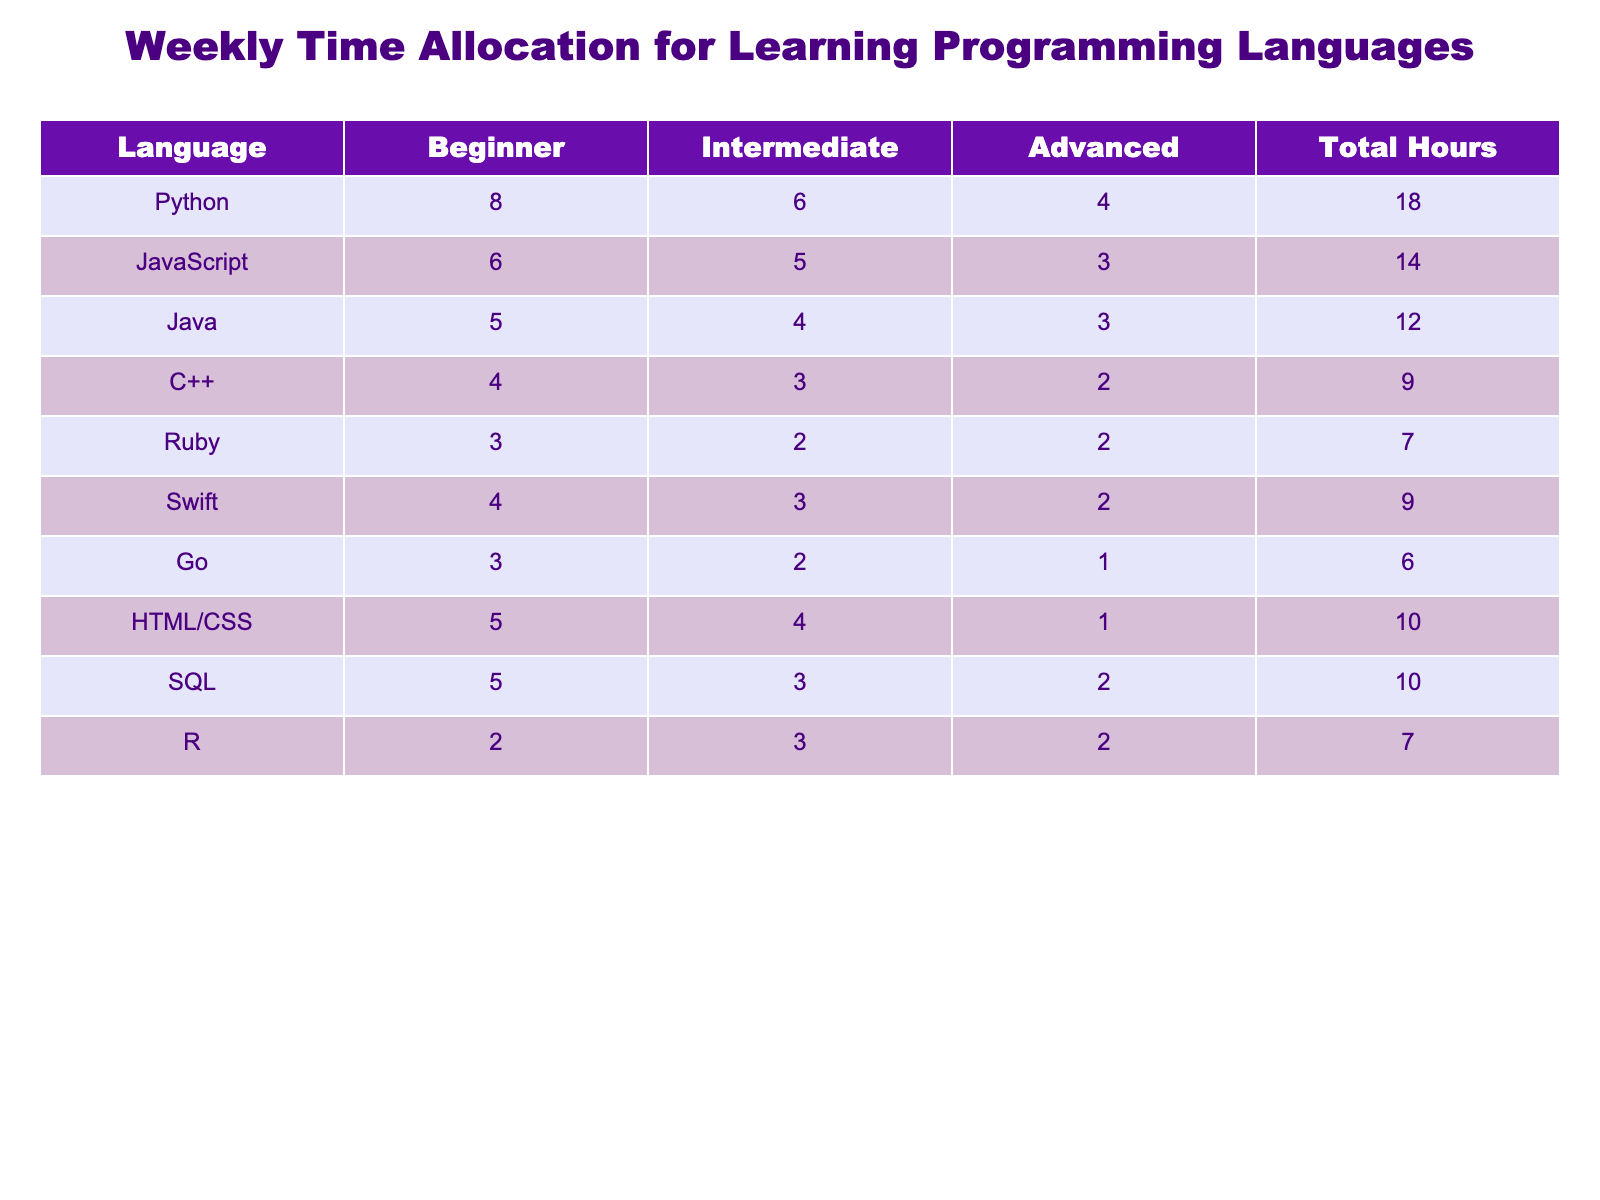What is the total number of hours allocated for learning Python? The total hours for Python can be found in the last column of the table. The row corresponding to Python shows a total of 18 hours.
Answer: 18 Which language has the highest total hours allocated for learning? To find the highest total hours, we compare the 'Total Hours' column values. Python has 18, JavaScript has 14, Java has 12, and so on. The highest is Python with 18 hours.
Answer: Python What is the average total hours allocated for all programming languages? First, we need to sum the total hours for all languages: 18 + 14 + 12 + 9 + 7 + 9 + 6 + 10 + 10 + 7 = 92. There are 10 languages, so the average is 92 divided by 10, which equals 9.2.
Answer: 9.2 Is it true that Ruby has more total hours than Go? We check the total hours for Ruby, which is 7, and compare it to Go, which has 6 hours. Since 7 is greater than 6, the statement is true.
Answer: Yes If we look at intermediate hours, which programming language has the least allocation? In the 'Intermediate' column, we list the hours: 6 for Python, 5 for JavaScript, 4 for Java, 3 for C++, 2 for Ruby, 3 for Swift, 2 for Go, 4 for HTML/CSS, 3 for SQL, and 3 for R. The least is Ruby and Go, both with 2 hours.
Answer: Ruby and Go How many more hours are allocated for beginners in Python compared to C++? For beginners, Python has 8 hours, and C++ has 4 hours. We subtract C++'s hours from Python's: 8 - 4 = 4, indicating 4 more hours are allocated for Python.
Answer: 4 Which programming language has an equal allocation of total hours for advanced and beginner levels? By looking at the 'Advanced' and 'Beginner' columns, we see that Ruby has 2 hours for both advanced and beginner. Checking other languages shows no other matches, thus becoming the only instance.
Answer: Ruby How many programming languages have a total hour allocation of 10 or more? We check the 'Total Hours' column for values of 10 or more: Python (18), JavaScript (14), Java (12), HTML/CSS (10), and SQL (10). There are 5 languages meeting this criterion.
Answer: 5 Which language's advanced hours are less than its beginner hours? We compare the 'Advanced' and 'Beginner' columns for each language: Python (4 vs 8), JavaScript (3 vs 6), Java (3 vs 5), C++ (2 vs 4), Ruby (2 vs 3), Swift (2 vs 4), Go (1 vs 3), HTML/CSS (1 vs 5), SQL (2 vs 5), and R (2 vs 2). All have less advanced hours than beginner except R. The ones satisfying this condition are C++, Ruby, Swift, Go, HTML/CSS, SQL.
Answer: C++, Ruby, Swift, Go, HTML/CSS, SQL 